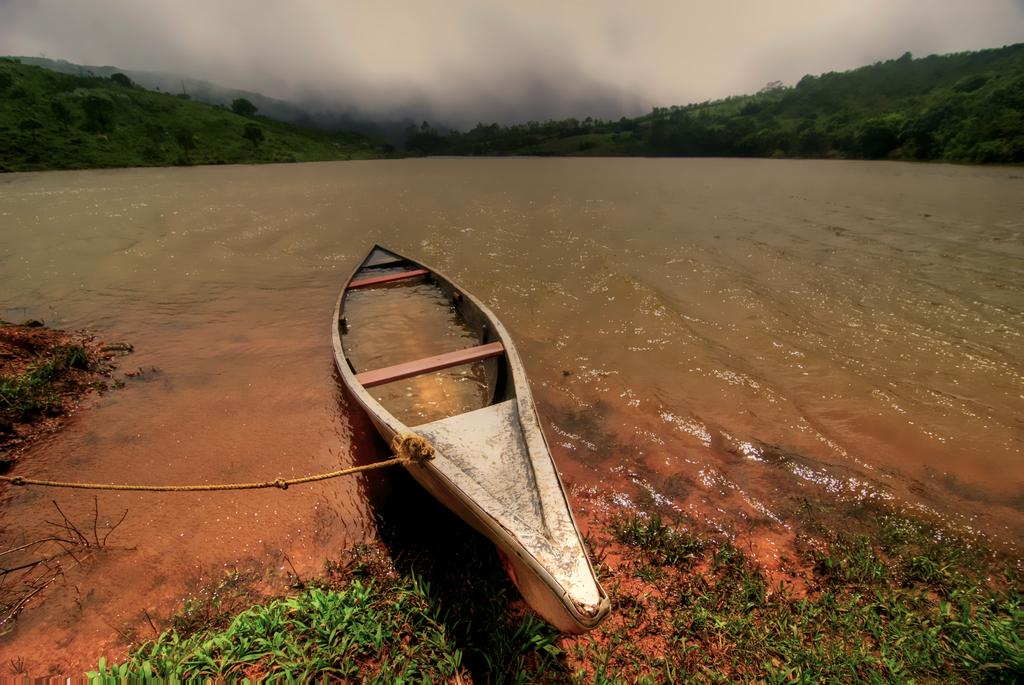What body of water is present in the image? There is a lake in the image. What is on the lake? There is a boat on the lake. What type of vegetation can be seen at the bottom of the image? There is grass at the bottom of the image. What can be seen in the distance in the image? There are hills in the background of the image. What is visible above the hills in the image? The sky is visible in the background of the image. Where are the silk plants located in the image? There are no silk plants present in the image. How many tomatoes can be seen growing on the hills in the image? There are no tomatoes visible in the image; only hills and the sky are present in the background. 